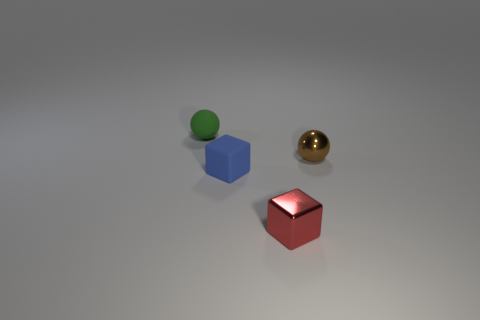What time of day does it look like based on the lighting in the image? The lighting in the image seems to be artificial, as evidenced by the soft shadows and the uniformly lit background. It creates an impression similar to what you'd see in an indoor setting under studio lighting. There are no indicators of natural light sources such as the sun, which makes it difficult to determine the time of day based strictly on the lighting. Could this lighting be used to infer anything about the environment in which the objects are placed? The controlled and diffused lighting suggests a setting that is likely professional and possibly intended for product photography or scientific observation. Such lighting is often used to minimize distracting reflections and give an accurate representation of the objects' colors and shapes. 